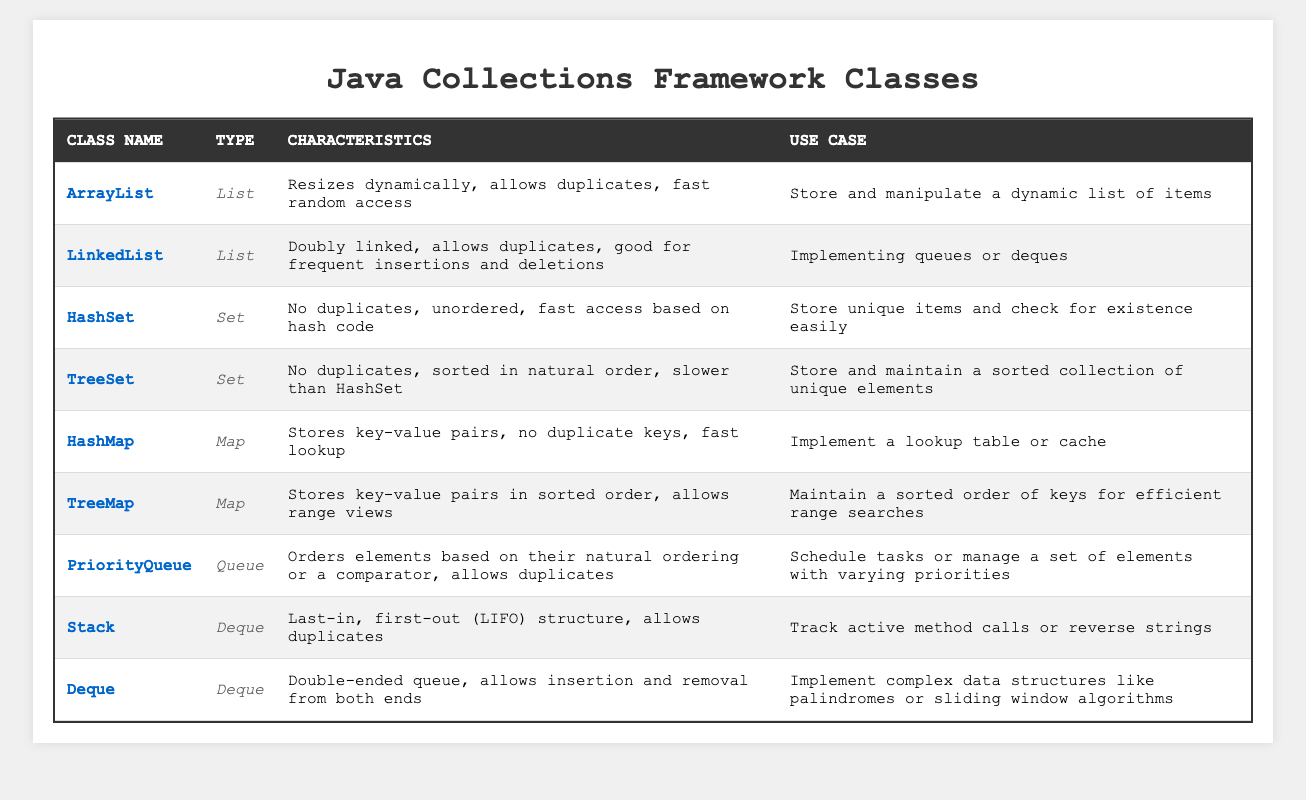What type of collection is ArrayList? According to the table, ArrayList belongs to the "List" type.
Answer: List Does HashSet allow duplicates? The table indicates that HashSet does not allow duplicates.
Answer: No Which Java collection class is designed to maintain a sorted order of elements? The table shows that TreeSet is the class designed to maintain a sorted collection of unique elements.
Answer: TreeSet What is the main use case of a PriorityQueue? Based on the table, the use case of a PriorityQueue is to schedule tasks or manage elements with varying priorities.
Answer: Schedule tasks Is TreeMap faster than HashMap for element lookups? The table does not provide a direct comparison on speed, but it mentions that HashMap offers fast lookup, suggesting it is generally faster than TreeMap.
Answer: No What characteristics does a LinkedList have? The table states that LinkedList is doubly linked, allows duplicates, and is good for frequent insertions and deletions.
Answer: Doubly linked, allows duplicates, good for insertions and deletions If you need a structure that allows removing elements from both ends, which class would you use? The table indicates that Deque allows insertion and removal from both ends, making it suitable for that requirement.
Answer: Deque Which collection class is best for implementing a lookup table or cache? HashMap is specified in the table as the best class for implementing a lookup table or cache.
Answer: HashMap What is the relationship between Stack and Deque? The table states that Stack is a type of Deque, because it operates under the Last-in, first-out (LIFO) principle.
Answer: Stack is a type of Deque How many unique types of collections are shown in the table? The table lists four unique types: List, Set, Map, and Queue/Deque. Counting them gives four different types.
Answer: Four Which class should you use if you want to store unique items efficiently? HashSet is indicated as the best class for storing unique items in the table.
Answer: HashSet 